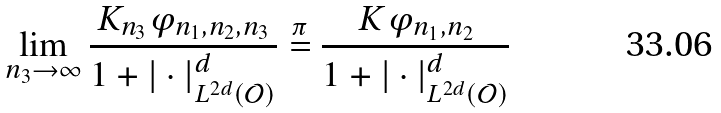Convert formula to latex. <formula><loc_0><loc_0><loc_500><loc_500>\lim _ { n _ { 3 } \to \infty } \frac { K _ { n _ { 3 } } \varphi _ { n _ { 1 } , n _ { 2 } , n _ { 3 } } } { 1 + | \cdot | _ { L ^ { 2 d } ( \mathcal { O } ) } ^ { d } } \stackrel { \pi } { = } \frac { K \varphi _ { n _ { 1 } , n _ { 2 } } } { 1 + | \cdot | _ { L ^ { 2 d } ( \mathcal { O } ) } ^ { d } }</formula> 